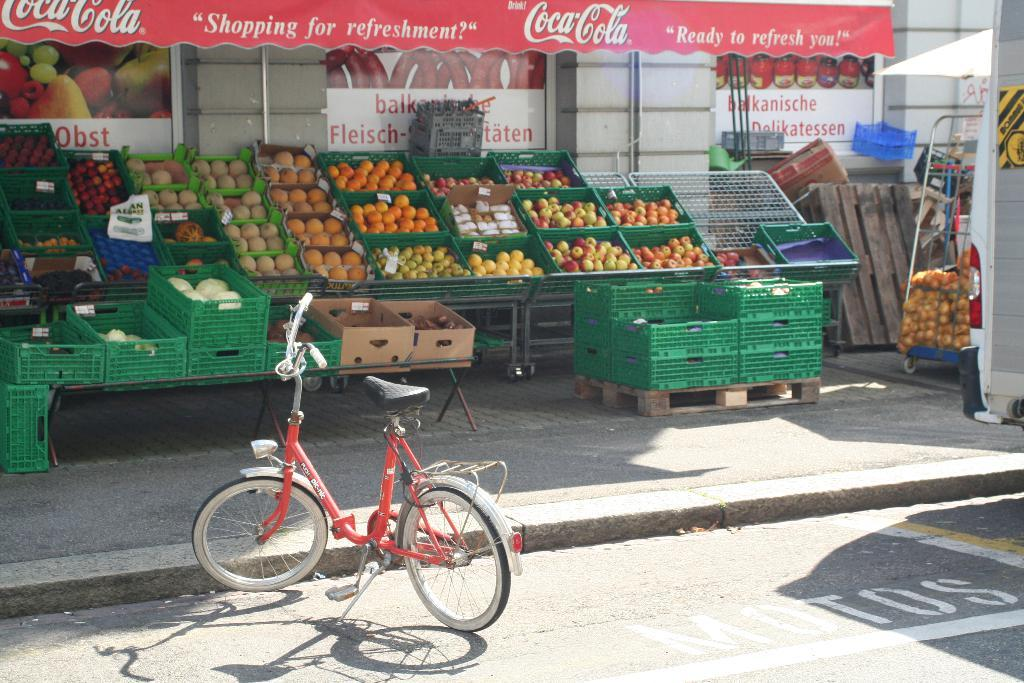<image>
Offer a succinct explanation of the picture presented. a fruit stand with a banner above it that says 'coca-cola' 